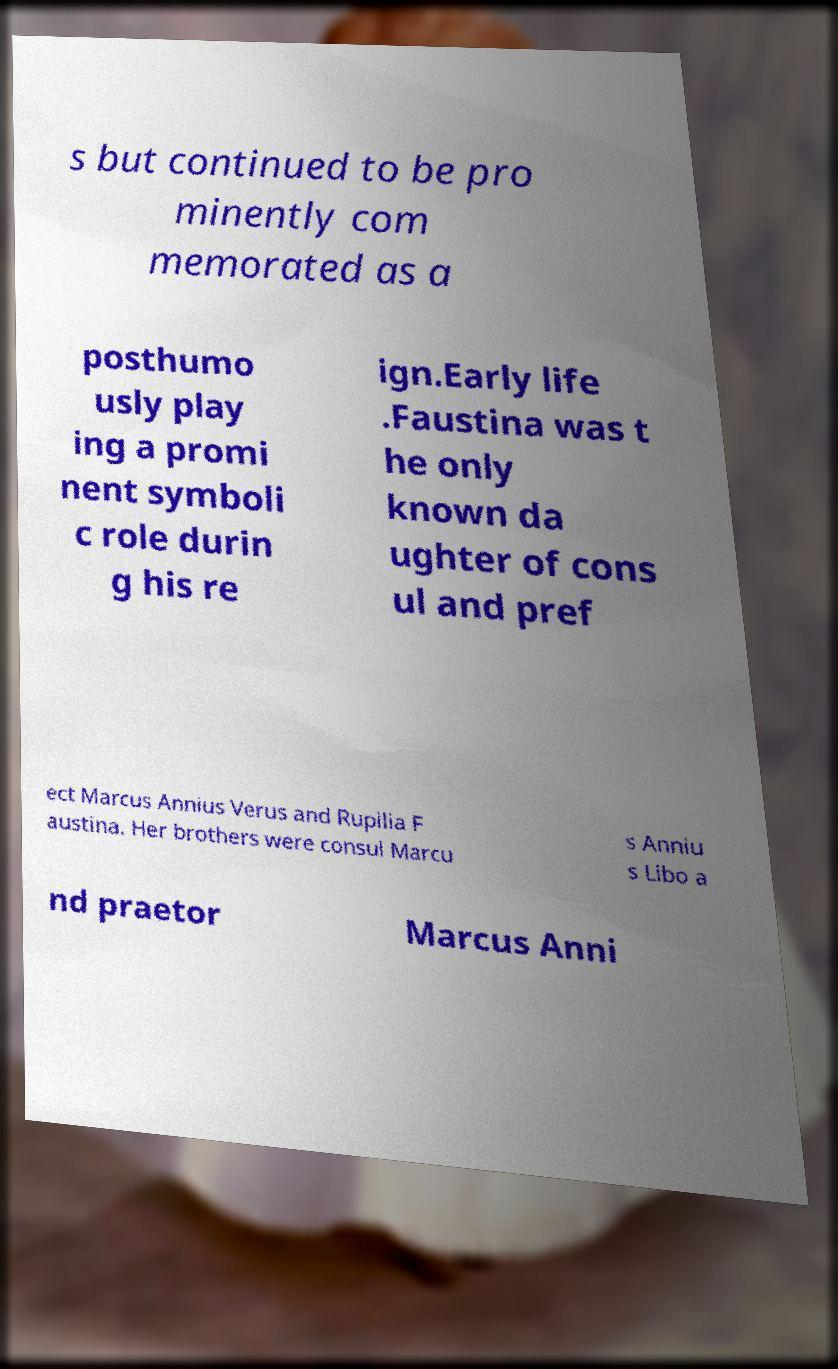Can you accurately transcribe the text from the provided image for me? s but continued to be pro minently com memorated as a posthumo usly play ing a promi nent symboli c role durin g his re ign.Early life .Faustina was t he only known da ughter of cons ul and pref ect Marcus Annius Verus and Rupilia F austina. Her brothers were consul Marcu s Anniu s Libo a nd praetor Marcus Anni 